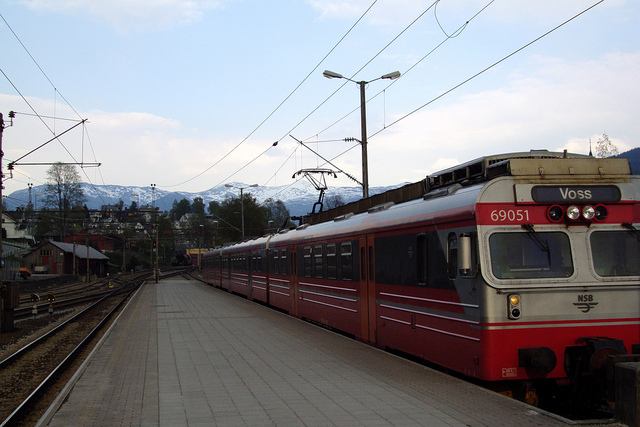<image>Was this photo taken from indoors looking outside? No, the photo was not taken from indoors looking outside. Was this photo taken from indoors looking outside? No, it was not taken from indoors looking outside. 